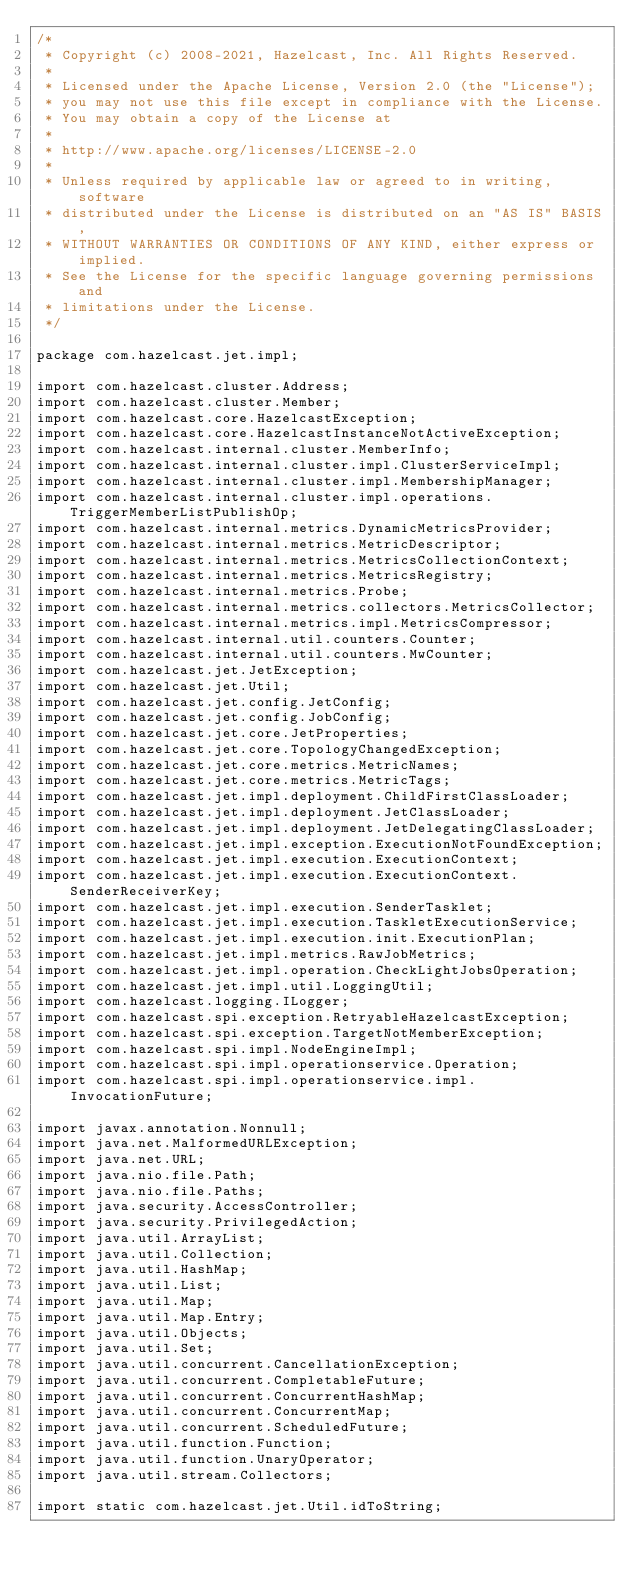<code> <loc_0><loc_0><loc_500><loc_500><_Java_>/*
 * Copyright (c) 2008-2021, Hazelcast, Inc. All Rights Reserved.
 *
 * Licensed under the Apache License, Version 2.0 (the "License");
 * you may not use this file except in compliance with the License.
 * You may obtain a copy of the License at
 *
 * http://www.apache.org/licenses/LICENSE-2.0
 *
 * Unless required by applicable law or agreed to in writing, software
 * distributed under the License is distributed on an "AS IS" BASIS,
 * WITHOUT WARRANTIES OR CONDITIONS OF ANY KIND, either express or implied.
 * See the License for the specific language governing permissions and
 * limitations under the License.
 */

package com.hazelcast.jet.impl;

import com.hazelcast.cluster.Address;
import com.hazelcast.cluster.Member;
import com.hazelcast.core.HazelcastException;
import com.hazelcast.core.HazelcastInstanceNotActiveException;
import com.hazelcast.internal.cluster.MemberInfo;
import com.hazelcast.internal.cluster.impl.ClusterServiceImpl;
import com.hazelcast.internal.cluster.impl.MembershipManager;
import com.hazelcast.internal.cluster.impl.operations.TriggerMemberListPublishOp;
import com.hazelcast.internal.metrics.DynamicMetricsProvider;
import com.hazelcast.internal.metrics.MetricDescriptor;
import com.hazelcast.internal.metrics.MetricsCollectionContext;
import com.hazelcast.internal.metrics.MetricsRegistry;
import com.hazelcast.internal.metrics.Probe;
import com.hazelcast.internal.metrics.collectors.MetricsCollector;
import com.hazelcast.internal.metrics.impl.MetricsCompressor;
import com.hazelcast.internal.util.counters.Counter;
import com.hazelcast.internal.util.counters.MwCounter;
import com.hazelcast.jet.JetException;
import com.hazelcast.jet.Util;
import com.hazelcast.jet.config.JetConfig;
import com.hazelcast.jet.config.JobConfig;
import com.hazelcast.jet.core.JetProperties;
import com.hazelcast.jet.core.TopologyChangedException;
import com.hazelcast.jet.core.metrics.MetricNames;
import com.hazelcast.jet.core.metrics.MetricTags;
import com.hazelcast.jet.impl.deployment.ChildFirstClassLoader;
import com.hazelcast.jet.impl.deployment.JetClassLoader;
import com.hazelcast.jet.impl.deployment.JetDelegatingClassLoader;
import com.hazelcast.jet.impl.exception.ExecutionNotFoundException;
import com.hazelcast.jet.impl.execution.ExecutionContext;
import com.hazelcast.jet.impl.execution.ExecutionContext.SenderReceiverKey;
import com.hazelcast.jet.impl.execution.SenderTasklet;
import com.hazelcast.jet.impl.execution.TaskletExecutionService;
import com.hazelcast.jet.impl.execution.init.ExecutionPlan;
import com.hazelcast.jet.impl.metrics.RawJobMetrics;
import com.hazelcast.jet.impl.operation.CheckLightJobsOperation;
import com.hazelcast.jet.impl.util.LoggingUtil;
import com.hazelcast.logging.ILogger;
import com.hazelcast.spi.exception.RetryableHazelcastException;
import com.hazelcast.spi.exception.TargetNotMemberException;
import com.hazelcast.spi.impl.NodeEngineImpl;
import com.hazelcast.spi.impl.operationservice.Operation;
import com.hazelcast.spi.impl.operationservice.impl.InvocationFuture;

import javax.annotation.Nonnull;
import java.net.MalformedURLException;
import java.net.URL;
import java.nio.file.Path;
import java.nio.file.Paths;
import java.security.AccessController;
import java.security.PrivilegedAction;
import java.util.ArrayList;
import java.util.Collection;
import java.util.HashMap;
import java.util.List;
import java.util.Map;
import java.util.Map.Entry;
import java.util.Objects;
import java.util.Set;
import java.util.concurrent.CancellationException;
import java.util.concurrent.CompletableFuture;
import java.util.concurrent.ConcurrentHashMap;
import java.util.concurrent.ConcurrentMap;
import java.util.concurrent.ScheduledFuture;
import java.util.function.Function;
import java.util.function.UnaryOperator;
import java.util.stream.Collectors;

import static com.hazelcast.jet.Util.idToString;</code> 